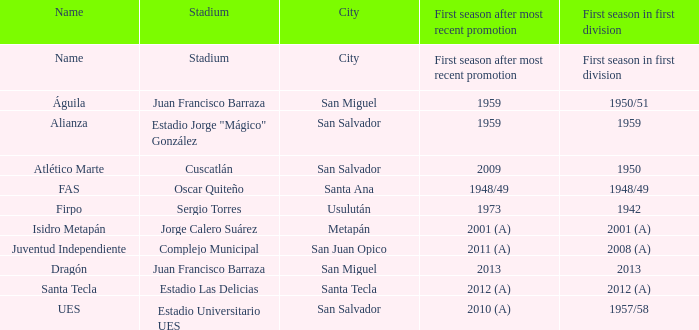Which city is Alianza? San Salvador. 